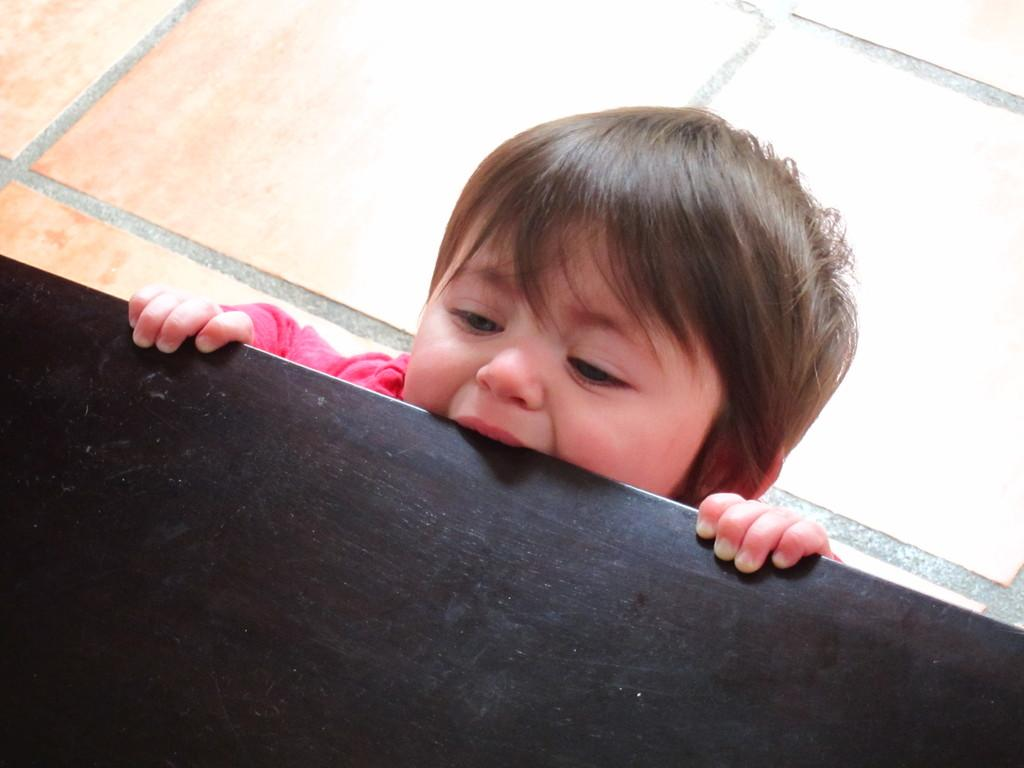What is the main subject of the image? There is a kid in the image. What is the kid doing in the image? The kid is standing on the floor and touching a table with his hands. What type of fish can be seen swimming in the image? There is no fish present in the image; it features a kid standing on the floor and touching a table. What type of silk material is draped over the table in the image? There is no silk material present in the image; it only shows a kid touching a table. 